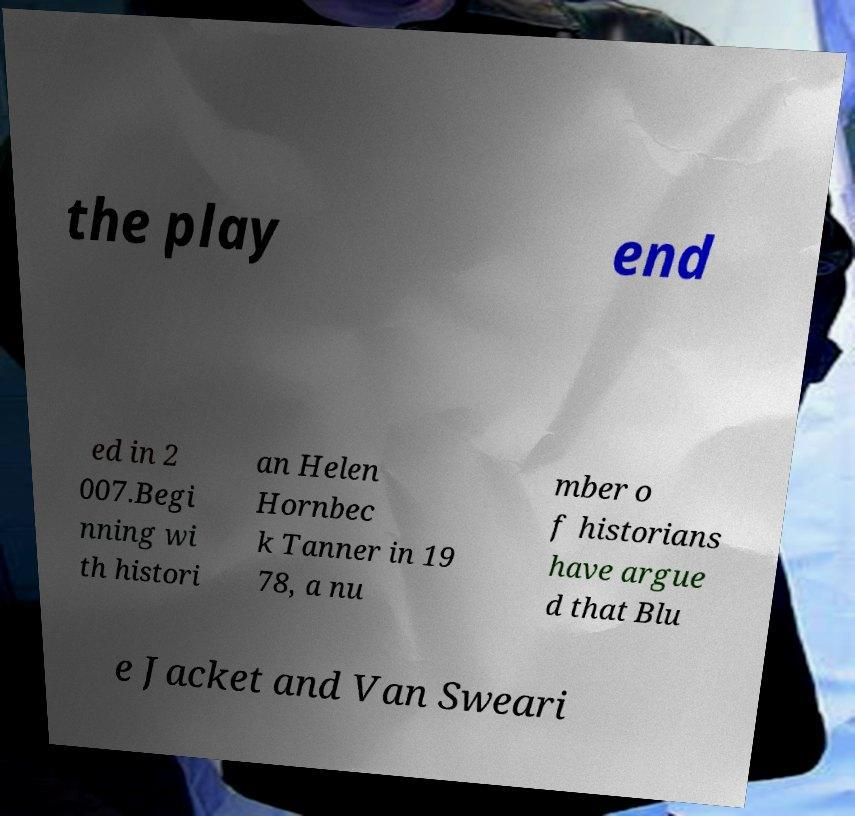Could you assist in decoding the text presented in this image and type it out clearly? the play end ed in 2 007.Begi nning wi th histori an Helen Hornbec k Tanner in 19 78, a nu mber o f historians have argue d that Blu e Jacket and Van Sweari 